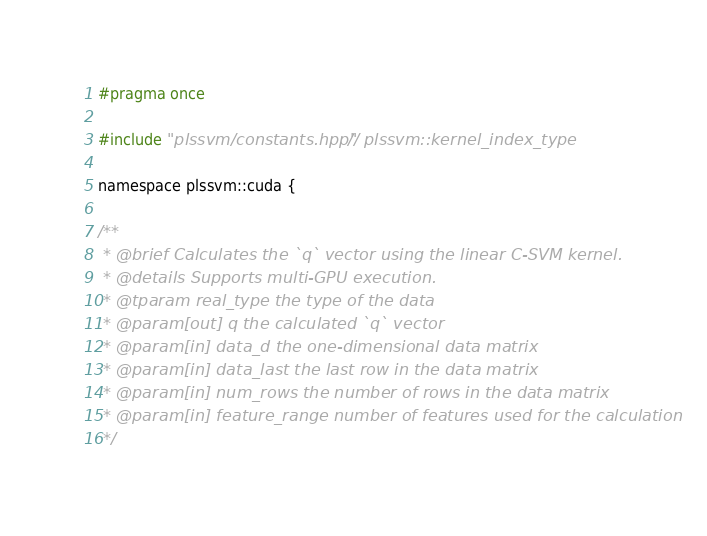<code> <loc_0><loc_0><loc_500><loc_500><_Cuda_>
#pragma once

#include "plssvm/constants.hpp"  // plssvm::kernel_index_type

namespace plssvm::cuda {

/**
 * @brief Calculates the `q` vector using the linear C-SVM kernel.
 * @details Supports multi-GPU execution.
 * @tparam real_type the type of the data
 * @param[out] q the calculated `q` vector
 * @param[in] data_d the one-dimensional data matrix
 * @param[in] data_last the last row in the data matrix
 * @param[in] num_rows the number of rows in the data matrix
 * @param[in] feature_range number of features used for the calculation
 */</code> 